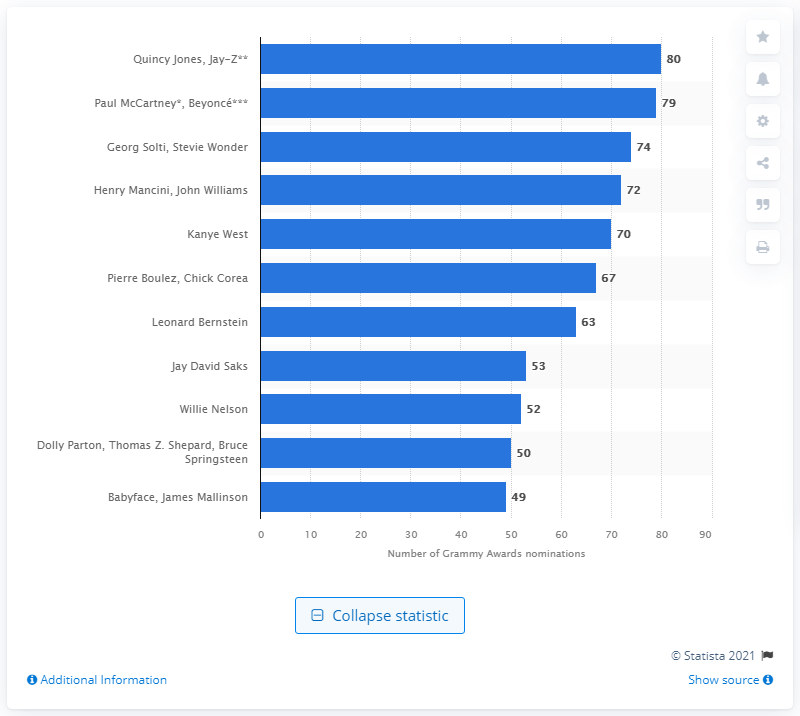Outline some significant characteristics in this image. Quincy Jones has been nominated for a total of 80 Grammy awards throughout his career. 